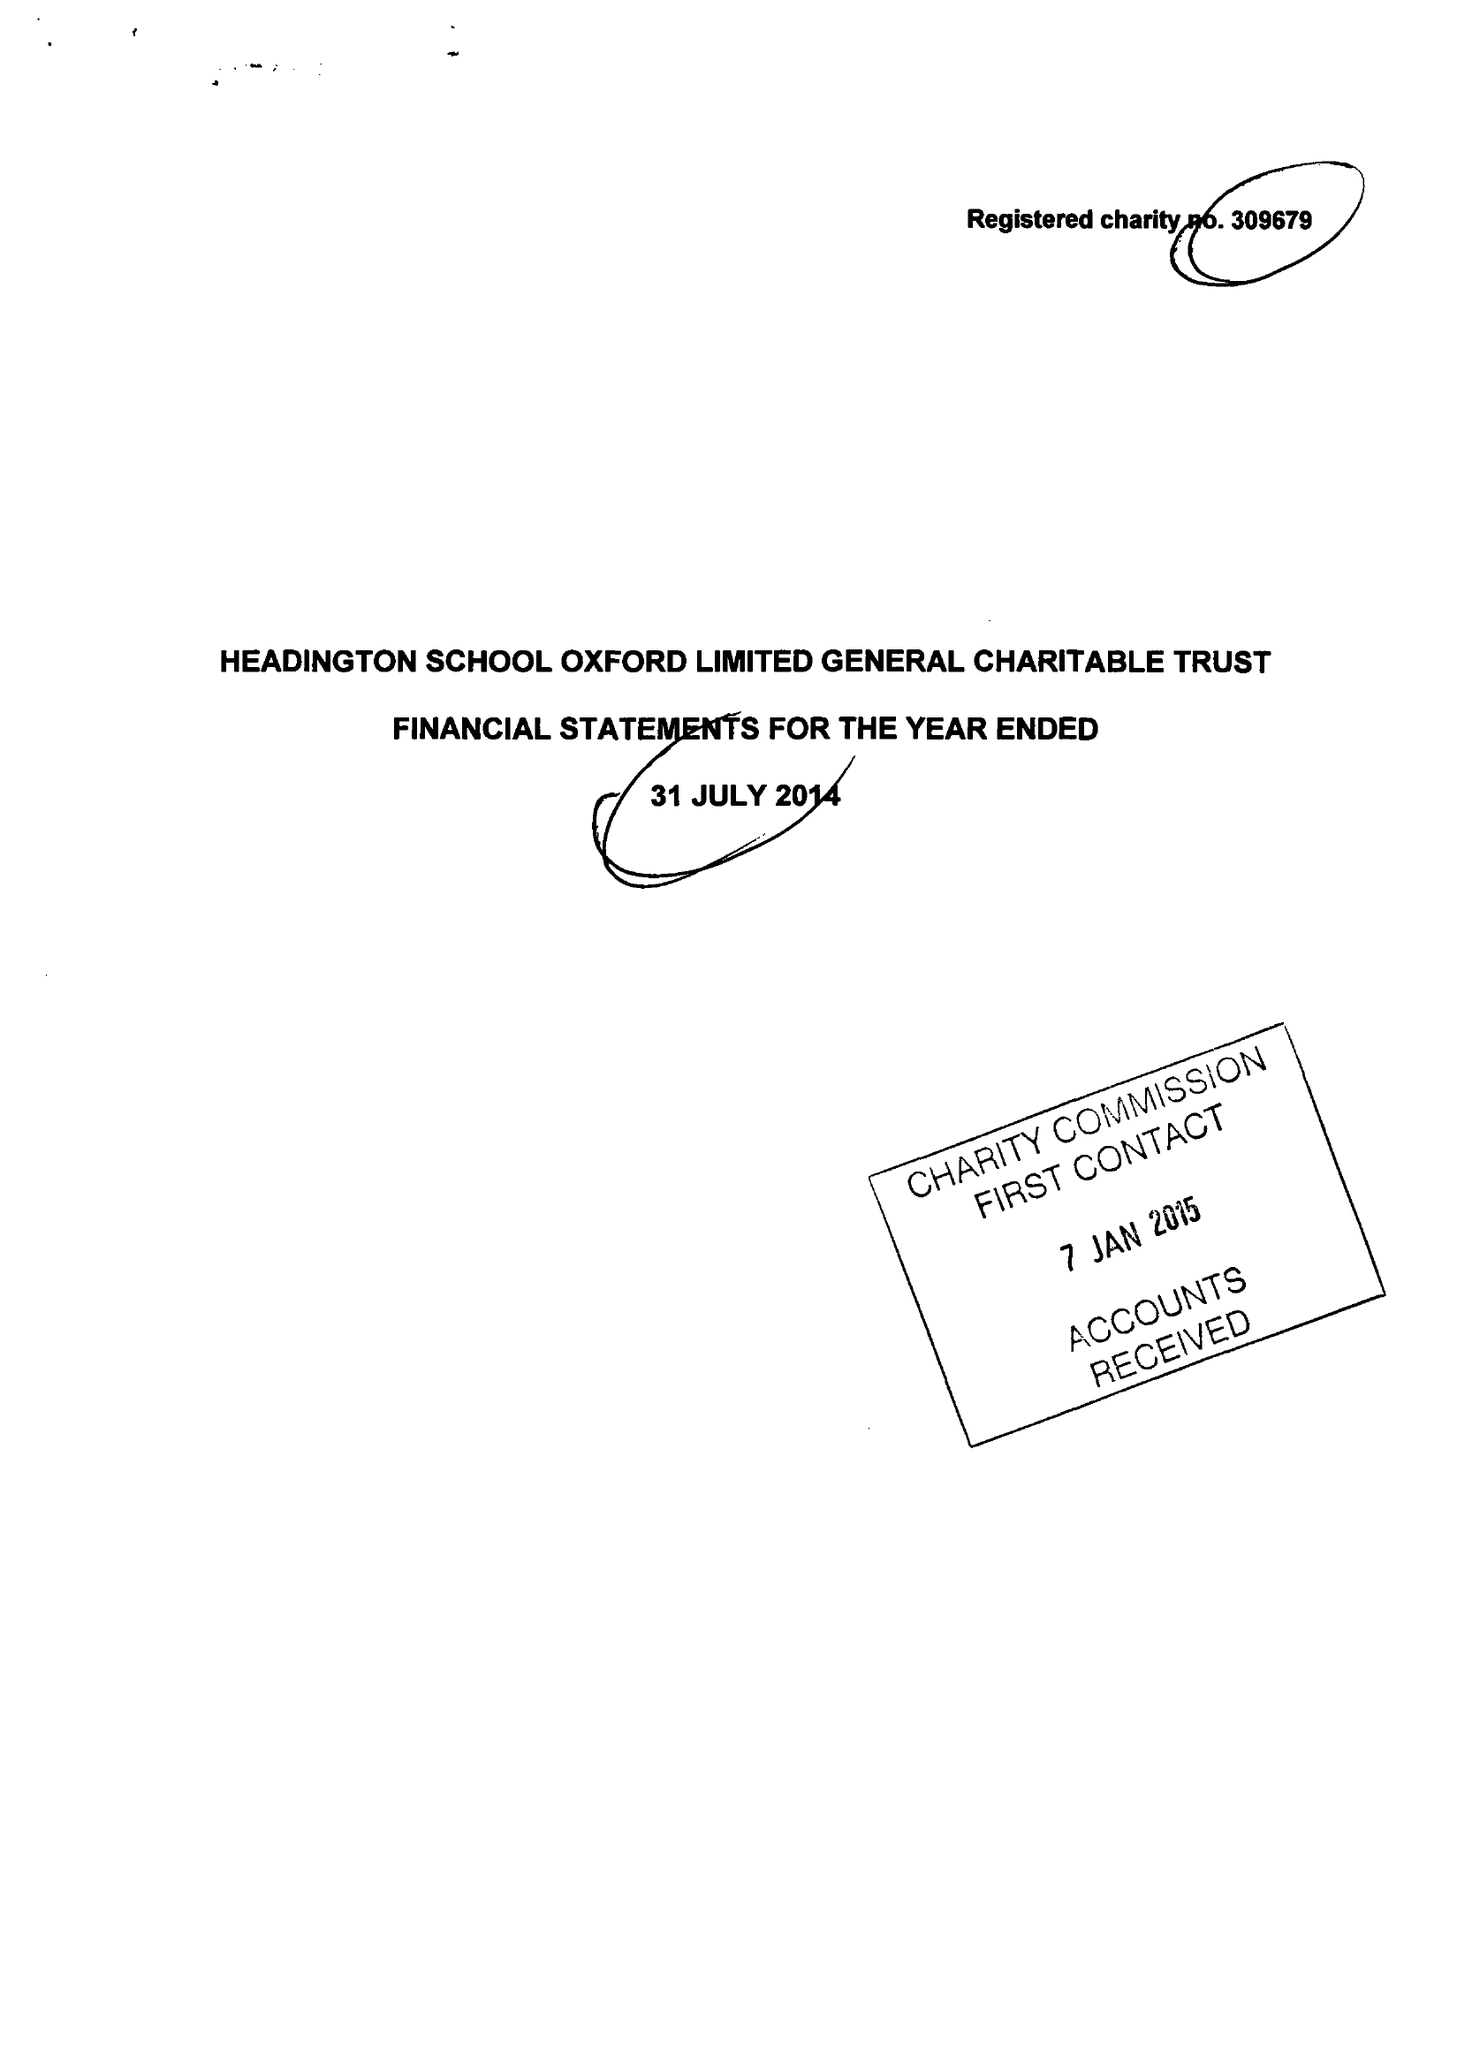What is the value for the income_annually_in_british_pounds?
Answer the question using a single word or phrase. 55255.00 